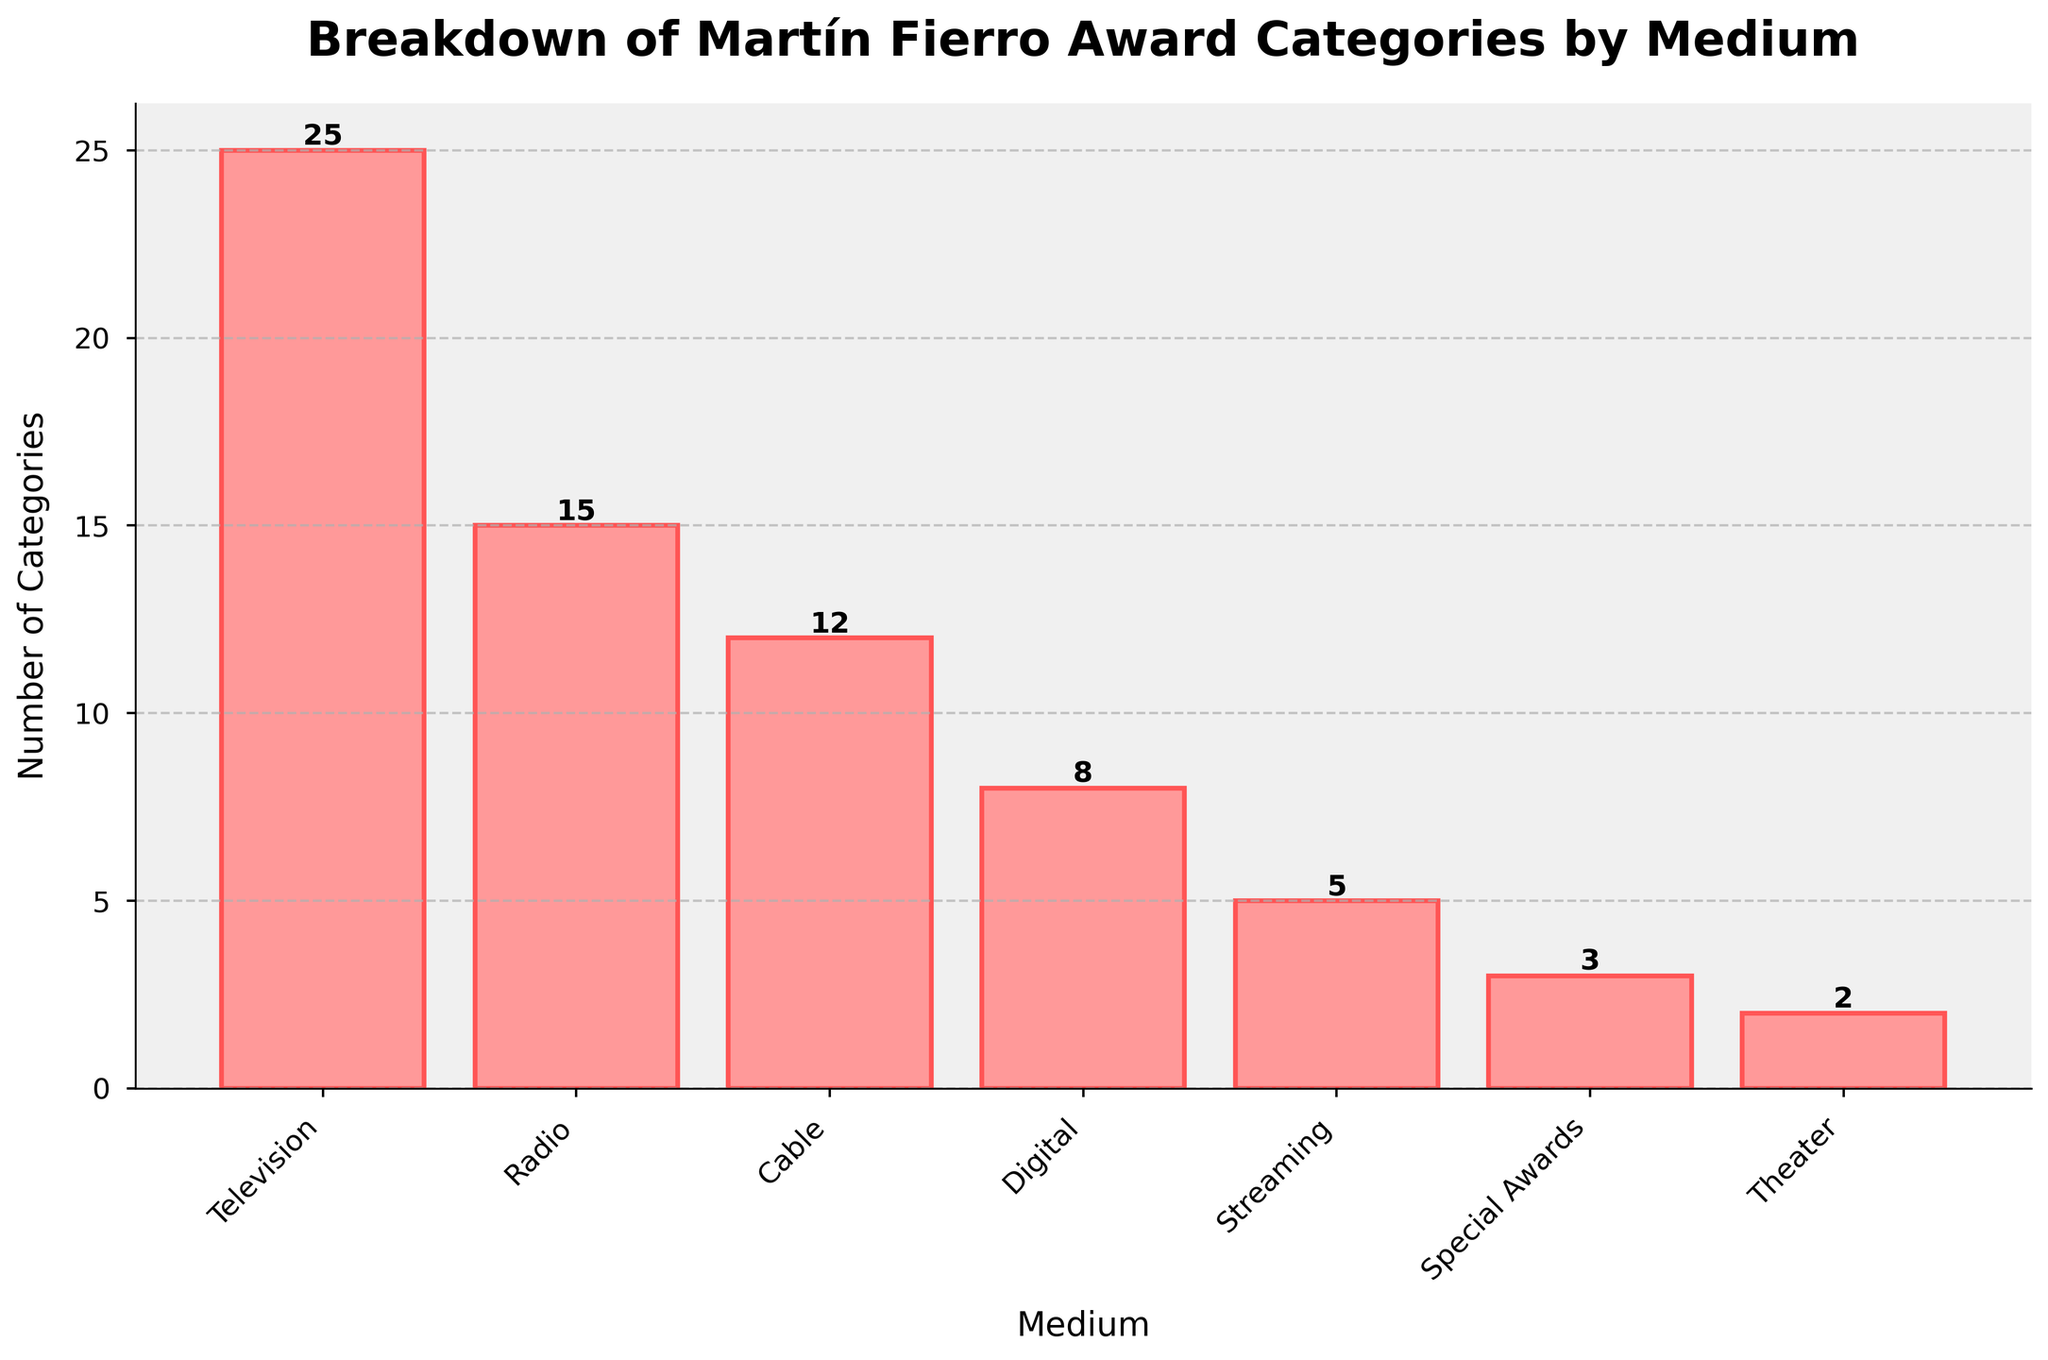Which medium has the most number of award categories? By looking at the heights of the bars, the bar representing 'Television' is the tallest, indicating that it has the most number of award categories.
Answer: Television How many more award categories does Television have compared to Radio? The height of the Television bar represents 25 categories while the Radio bar represents 15 categories. The difference is calculated as 25 - 15.
Answer: 10 What is the total number of award categories across all mediums except for Special Awards and Theater? Adding the categories for Television (25), Radio (15), Cable (12), Digital (8), and Streaming (5): 25 + 15 + 12 + 8 + 5 = 65.
Answer: 65 Is the number of Digital award categories greater than the number of Theater award categories? The height of the Digital bar is clearly greater than that of the Theater bar. Digital has 8 categories while Theater has 2 categories.
Answer: Yes Which mediums have fewer than 10 award categories? The bars representing Digital, Streaming, and Theater are shorter than the bar at the 10 category mark. Digital has 8, Streaming 5, and Theater 2 categories.
Answer: Digital, Streaming, Theater What is the average number of categories for Television, Radio, and Cable combined? Sum the categories for these three mediums and then divide by 3. (25 for Television, 15 for Radio, 12 for Cable). (25 + 15 + 12) / 3 = 52 / 3 = ~17.33.
Answer: ~17.33 How does the bar color influence the readability of the categories for each medium? The bars are colored in a soft red with a darker red outline, making each bar stand out clearly against the light background, enhancing readability by ensuring adequate contrast.
Answer: Enhances readability If you combine the categories of Streaming and Theater, does their total surpass that of Digital? Streaming has 5 categories and Theater has 2, together this makes 7. Digital has 8 categories, so 8 is greater than 7.
Answer: No How does the number of categories for Cable compare to those for Streaming? The height of the Cable bar (12) is significantly taller than that of the Streaming bar (5).
Answer: Cable has more By how many categories does the combined total of Special Awards and Theater fall short of Radio categories? Combining Special Awards (3) and Theater (2) gives 5. Radio has 15 categories. The shortfall is calculated as 15 - 5 = 10.
Answer: 10 